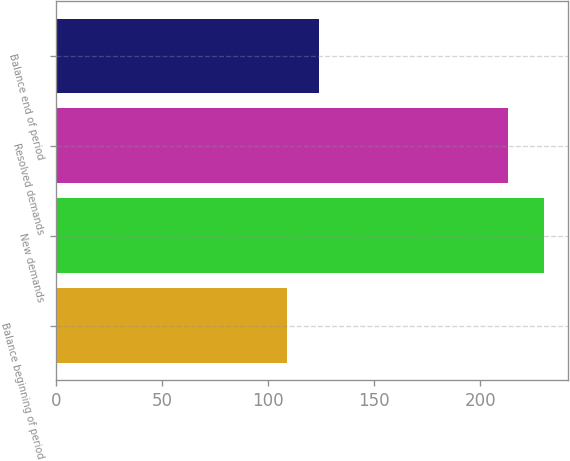Convert chart to OTSL. <chart><loc_0><loc_0><loc_500><loc_500><bar_chart><fcel>Balance beginning of period<fcel>New demands<fcel>Resolved demands<fcel>Balance end of period<nl><fcel>109<fcel>230<fcel>213<fcel>124<nl></chart> 